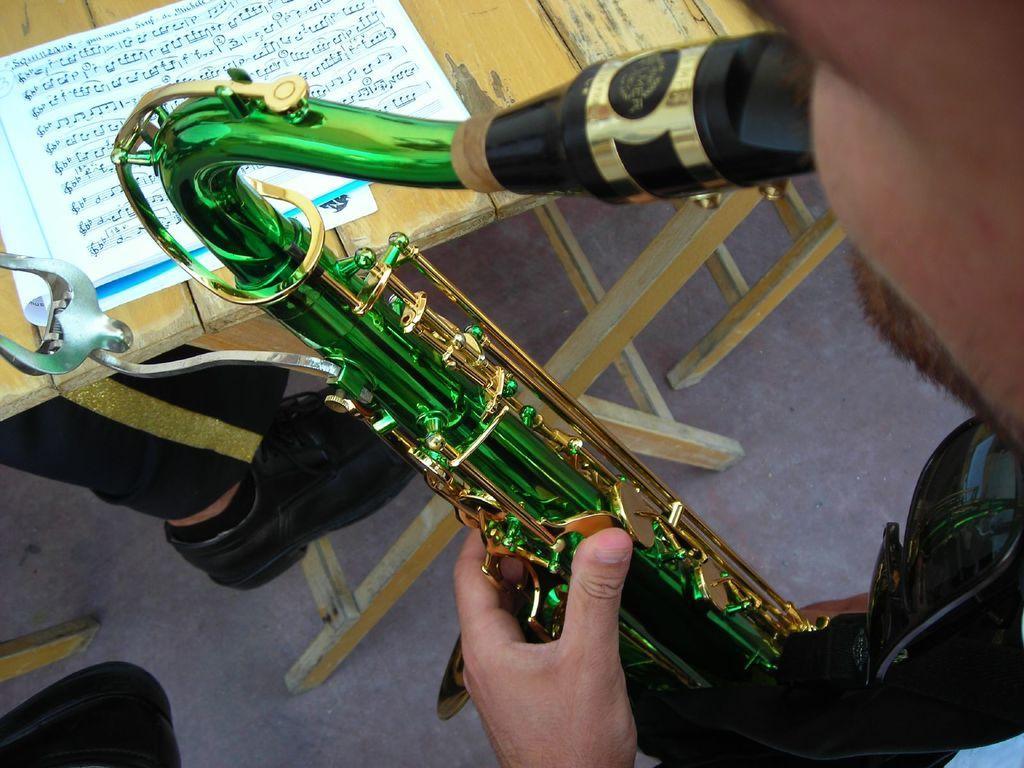Can you describe this image briefly? In this picture there is a man who is holding a green and golden color flute. On the table I can see the papers. On the left I can see the person's leg who is wearing trouser and shoe. In the bottom left corner I can see the black objects. 